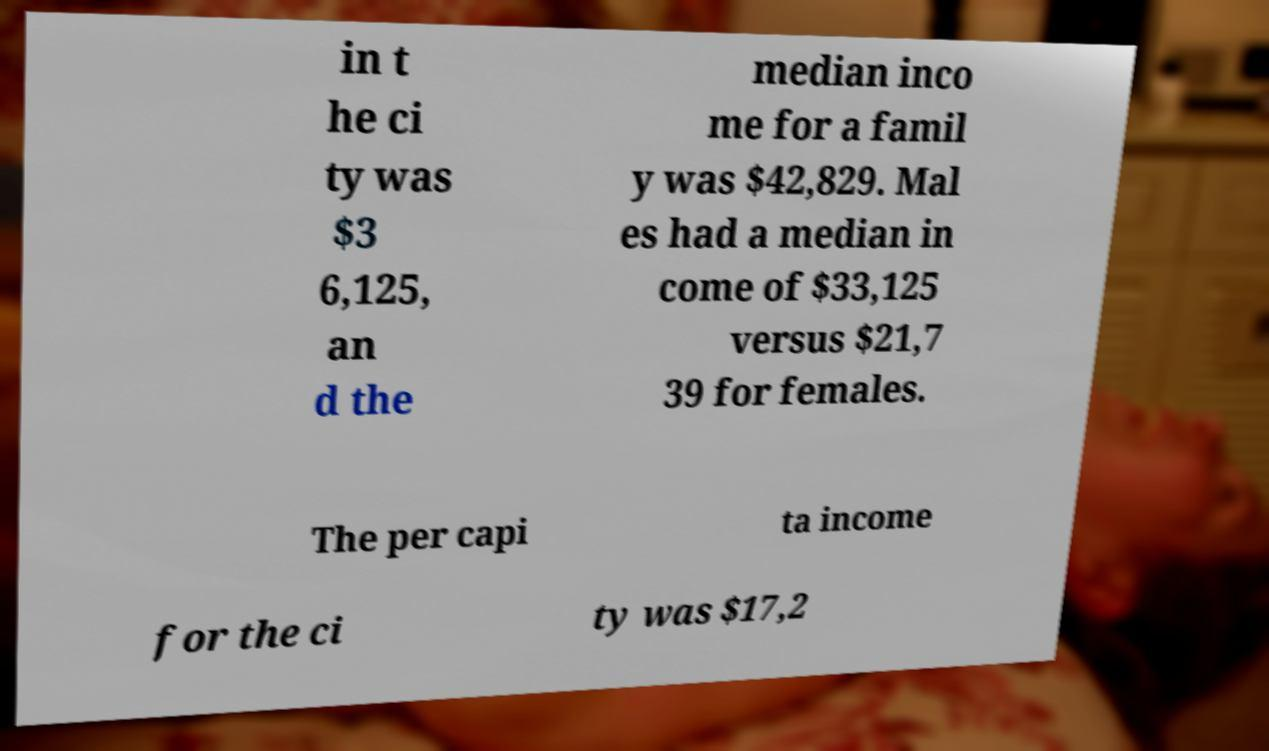For documentation purposes, I need the text within this image transcribed. Could you provide that? in t he ci ty was $3 6,125, an d the median inco me for a famil y was $42,829. Mal es had a median in come of $33,125 versus $21,7 39 for females. The per capi ta income for the ci ty was $17,2 